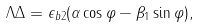Convert formula to latex. <formula><loc_0><loc_0><loc_500><loc_500>\Lambda \Delta = \epsilon _ { b 2 } ( \alpha \cos \varphi - \beta _ { 1 } \sin \varphi ) ,</formula> 